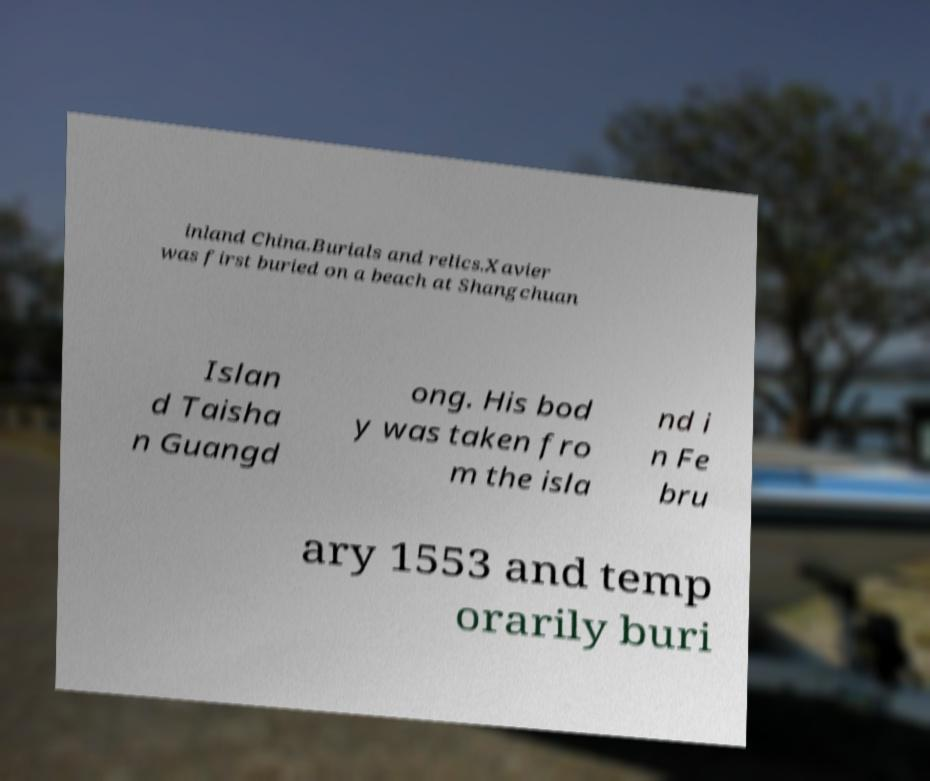Please read and relay the text visible in this image. What does it say? inland China.Burials and relics.Xavier was first buried on a beach at Shangchuan Islan d Taisha n Guangd ong. His bod y was taken fro m the isla nd i n Fe bru ary 1553 and temp orarily buri 